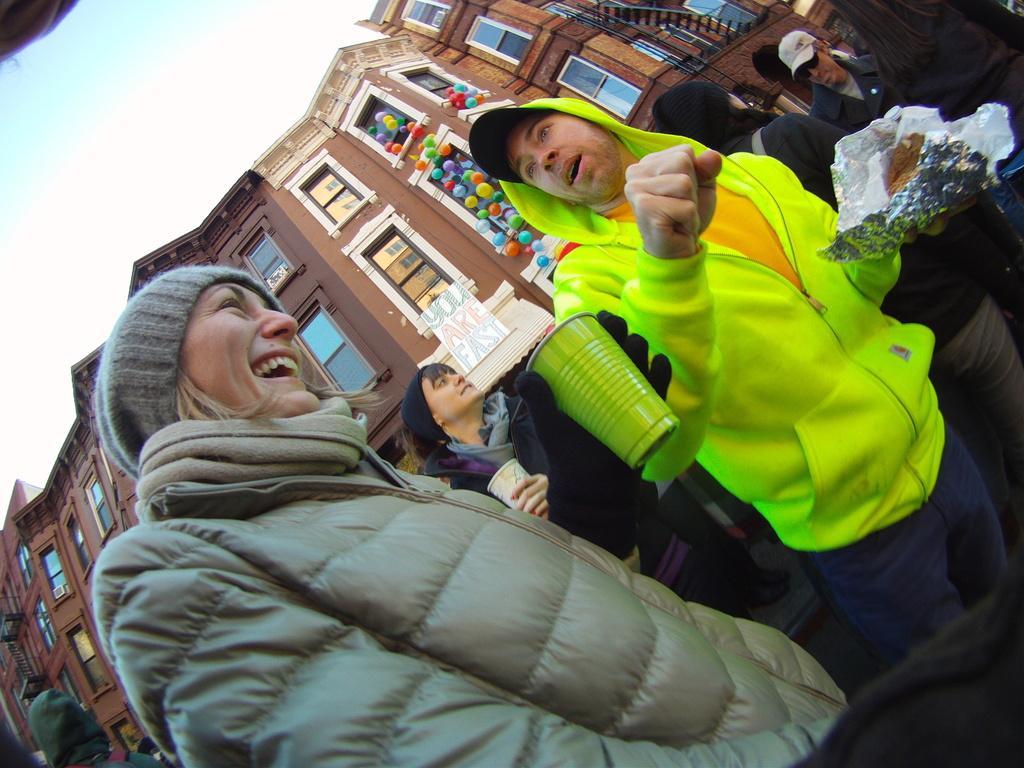Could you give a brief overview of what you see in this image? In this image there are people standing and holding cups, papers, in their hand, in the background there is a building and a sky. 